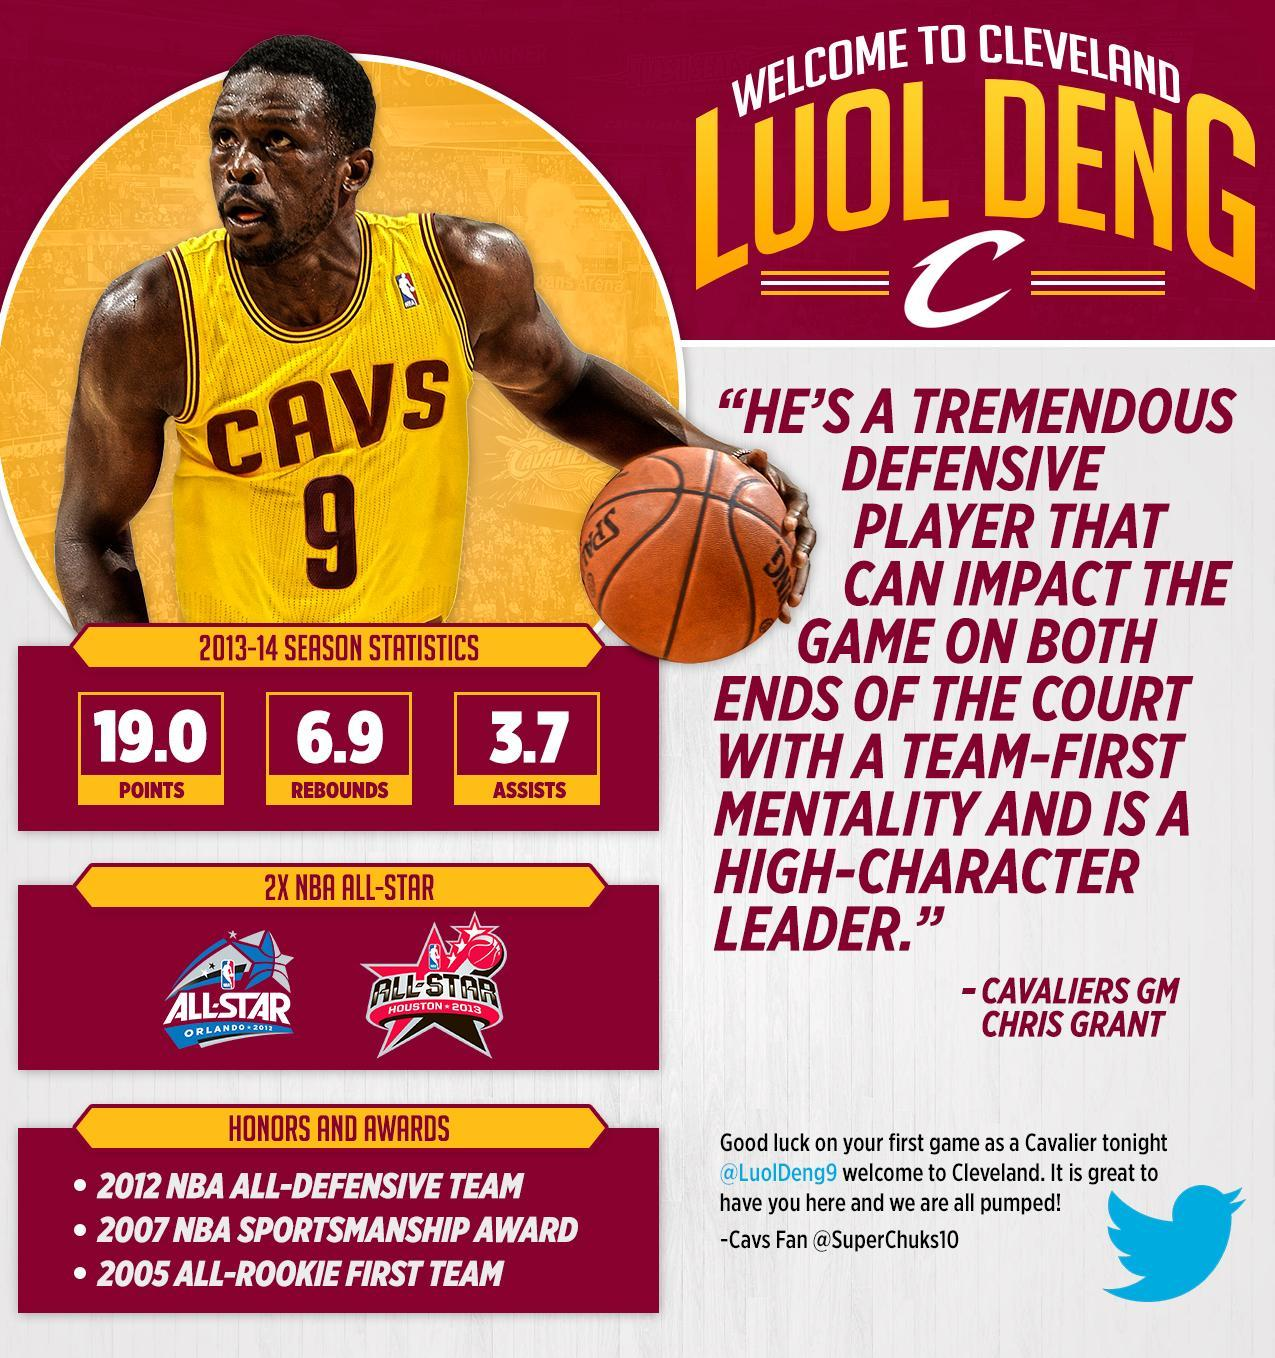How many honors and awards for Cleveland Cavaliers?
Answer the question with a short phrase. 3 How many points for Cleveland Cavaliers in the 2013-14 season? 19.0 